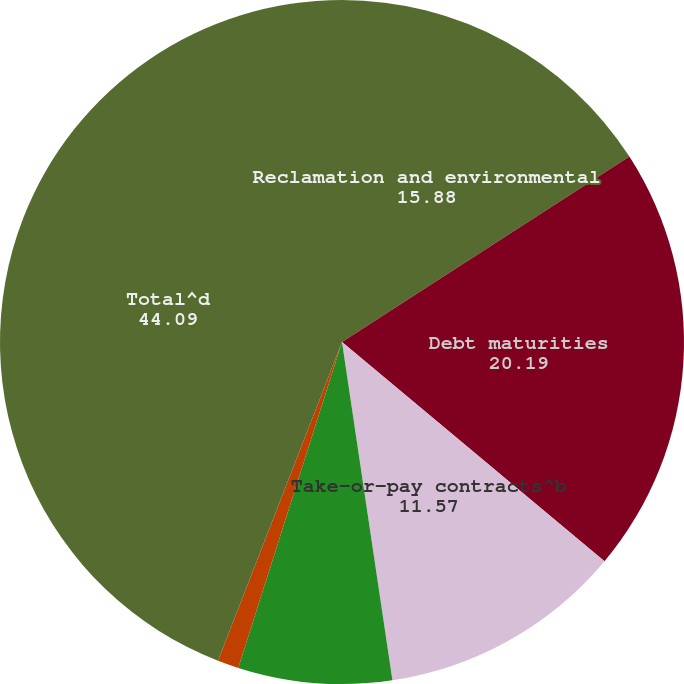Convert chart to OTSL. <chart><loc_0><loc_0><loc_500><loc_500><pie_chart><fcel>Reclamation and environmental<fcel>Debt maturities<fcel>Take-or-pay contracts^b<fcel>Scheduled interest payment<fcel>Operating lease obligations<fcel>Total^d<nl><fcel>15.88%<fcel>20.19%<fcel>11.57%<fcel>7.26%<fcel>1.0%<fcel>44.09%<nl></chart> 